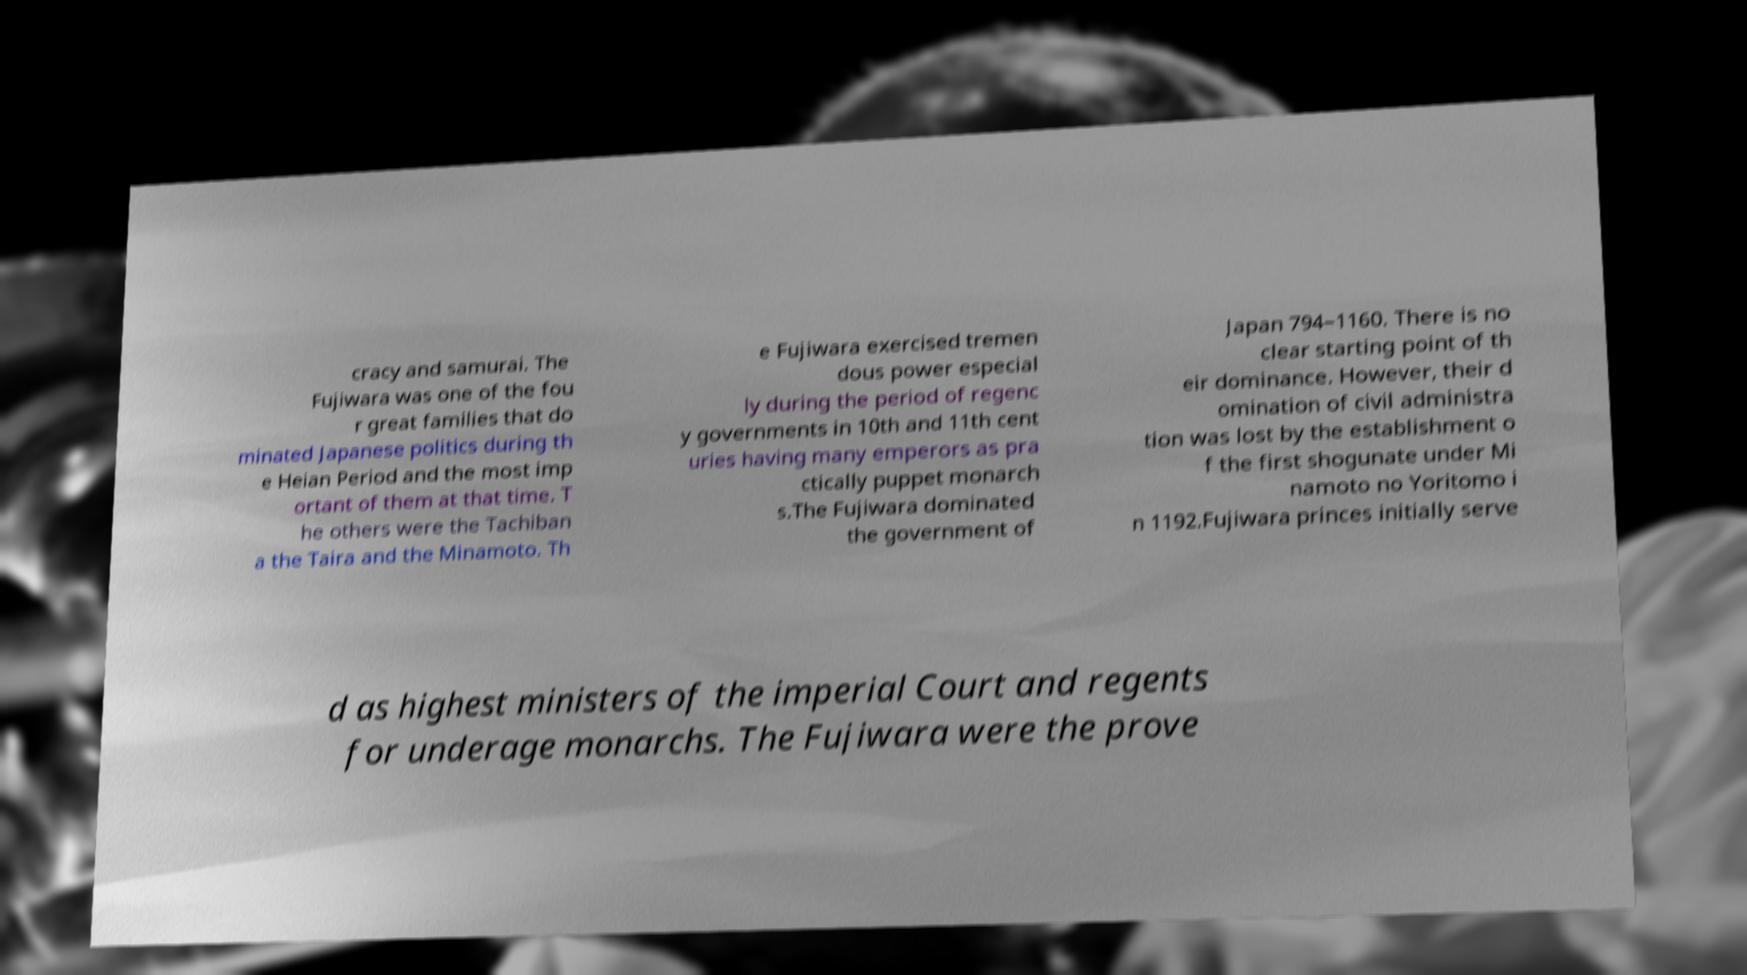I need the written content from this picture converted into text. Can you do that? cracy and samurai. The Fujiwara was one of the fou r great families that do minated Japanese politics during th e Heian Period and the most imp ortant of them at that time. T he others were the Tachiban a the Taira and the Minamoto. Th e Fujiwara exercised tremen dous power especial ly during the period of regenc y governments in 10th and 11th cent uries having many emperors as pra ctically puppet monarch s.The Fujiwara dominated the government of Japan 794–1160. There is no clear starting point of th eir dominance. However, their d omination of civil administra tion was lost by the establishment o f the first shogunate under Mi namoto no Yoritomo i n 1192.Fujiwara princes initially serve d as highest ministers of the imperial Court and regents for underage monarchs. The Fujiwara were the prove 